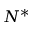Convert formula to latex. <formula><loc_0><loc_0><loc_500><loc_500>N ^ { * }</formula> 